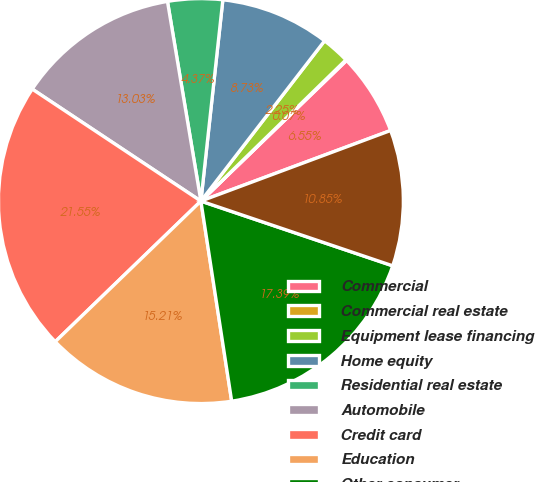Convert chart to OTSL. <chart><loc_0><loc_0><loc_500><loc_500><pie_chart><fcel>Commercial<fcel>Commercial real estate<fcel>Equipment lease financing<fcel>Home equity<fcel>Residential real estate<fcel>Automobile<fcel>Credit card<fcel>Education<fcel>Other consumer<fcel>Total<nl><fcel>6.55%<fcel>0.07%<fcel>2.25%<fcel>8.73%<fcel>4.37%<fcel>13.03%<fcel>21.55%<fcel>15.21%<fcel>17.39%<fcel>10.85%<nl></chart> 